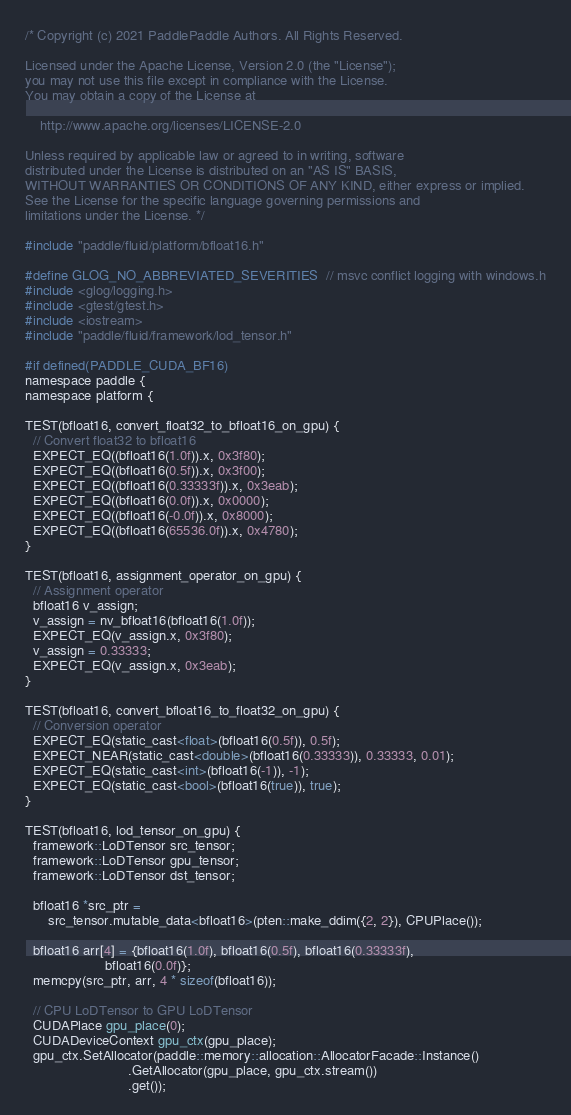Convert code to text. <code><loc_0><loc_0><loc_500><loc_500><_Cuda_>/* Copyright (c) 2021 PaddlePaddle Authors. All Rights Reserved.

Licensed under the Apache License, Version 2.0 (the "License");
you may not use this file except in compliance with the License.
You may obtain a copy of the License at

    http://www.apache.org/licenses/LICENSE-2.0

Unless required by applicable law or agreed to in writing, software
distributed under the License is distributed on an "AS IS" BASIS,
WITHOUT WARRANTIES OR CONDITIONS OF ANY KIND, either express or implied.
See the License for the specific language governing permissions and
limitations under the License. */

#include "paddle/fluid/platform/bfloat16.h"

#define GLOG_NO_ABBREVIATED_SEVERITIES  // msvc conflict logging with windows.h
#include <glog/logging.h>
#include <gtest/gtest.h>
#include <iostream>
#include "paddle/fluid/framework/lod_tensor.h"

#if defined(PADDLE_CUDA_BF16)
namespace paddle {
namespace platform {

TEST(bfloat16, convert_float32_to_bfloat16_on_gpu) {
  // Convert float32 to bfloat16
  EXPECT_EQ((bfloat16(1.0f)).x, 0x3f80);
  EXPECT_EQ((bfloat16(0.5f)).x, 0x3f00);
  EXPECT_EQ((bfloat16(0.33333f)).x, 0x3eab);
  EXPECT_EQ((bfloat16(0.0f)).x, 0x0000);
  EXPECT_EQ((bfloat16(-0.0f)).x, 0x8000);
  EXPECT_EQ((bfloat16(65536.0f)).x, 0x4780);
}

TEST(bfloat16, assignment_operator_on_gpu) {
  // Assignment operator
  bfloat16 v_assign;
  v_assign = nv_bfloat16(bfloat16(1.0f));
  EXPECT_EQ(v_assign.x, 0x3f80);
  v_assign = 0.33333;
  EXPECT_EQ(v_assign.x, 0x3eab);
}

TEST(bfloat16, convert_bfloat16_to_float32_on_gpu) {
  // Conversion operator
  EXPECT_EQ(static_cast<float>(bfloat16(0.5f)), 0.5f);
  EXPECT_NEAR(static_cast<double>(bfloat16(0.33333)), 0.33333, 0.01);
  EXPECT_EQ(static_cast<int>(bfloat16(-1)), -1);
  EXPECT_EQ(static_cast<bool>(bfloat16(true)), true);
}

TEST(bfloat16, lod_tensor_on_gpu) {
  framework::LoDTensor src_tensor;
  framework::LoDTensor gpu_tensor;
  framework::LoDTensor dst_tensor;

  bfloat16 *src_ptr =
      src_tensor.mutable_data<bfloat16>(pten::make_ddim({2, 2}), CPUPlace());

  bfloat16 arr[4] = {bfloat16(1.0f), bfloat16(0.5f), bfloat16(0.33333f),
                     bfloat16(0.0f)};
  memcpy(src_ptr, arr, 4 * sizeof(bfloat16));

  // CPU LoDTensor to GPU LoDTensor
  CUDAPlace gpu_place(0);
  CUDADeviceContext gpu_ctx(gpu_place);
  gpu_ctx.SetAllocator(paddle::memory::allocation::AllocatorFacade::Instance()
                           .GetAllocator(gpu_place, gpu_ctx.stream())
                           .get());</code> 